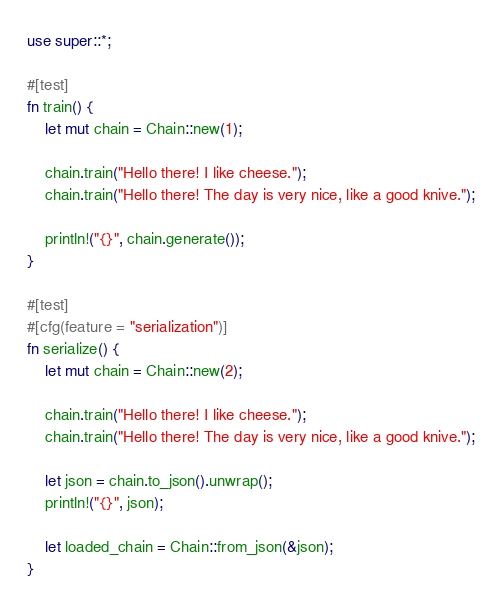<code> <loc_0><loc_0><loc_500><loc_500><_Rust_>use super::*;

#[test]
fn train() {
    let mut chain = Chain::new(1);

    chain.train("Hello there! I like cheese.");
    chain.train("Hello there! The day is very nice, like a good knive.");

    println!("{}", chain.generate());
}

#[test]
#[cfg(feature = "serialization")]
fn serialize() {
    let mut chain = Chain::new(2);

    chain.train("Hello there! I like cheese.");
    chain.train("Hello there! The day is very nice, like a good knive.");

    let json = chain.to_json().unwrap();
    println!("{}", json);

    let loaded_chain = Chain::from_json(&json);
}
</code> 